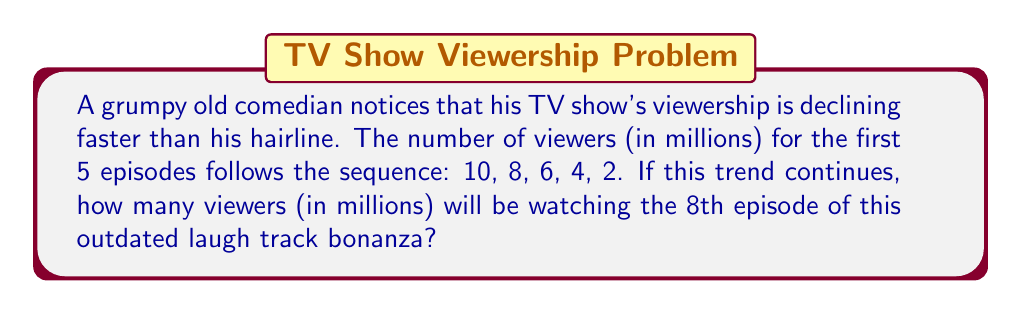Teach me how to tackle this problem. Let's approach this step-by-step:

1) First, we need to identify the pattern in the sequence:
   10, 8, 6, 4, 2

2) We can see that each term is decreasing by 2 from the previous term.

3) This is an arithmetic sequence with a common difference of -2.

4) The formula for the nth term of an arithmetic sequence is:

   $$ a_n = a_1 + (n-1)d $$

   Where:
   $a_n$ is the nth term
   $a_1$ is the first term
   $n$ is the position of the term
   $d$ is the common difference

5) In this case:
   $a_1 = 10$ (first term)
   $d = -2$ (common difference)
   We want to find $a_8$ (8th term)

6) Plugging these values into the formula:

   $$ a_8 = 10 + (8-1)(-2) $$
   $$ a_8 = 10 + (7)(-2) $$
   $$ a_8 = 10 - 14 $$
   $$ a_8 = -4 $$

7) However, we can't have negative viewers. The viewership will bottom out at 0.
Answer: 0 million viewers 